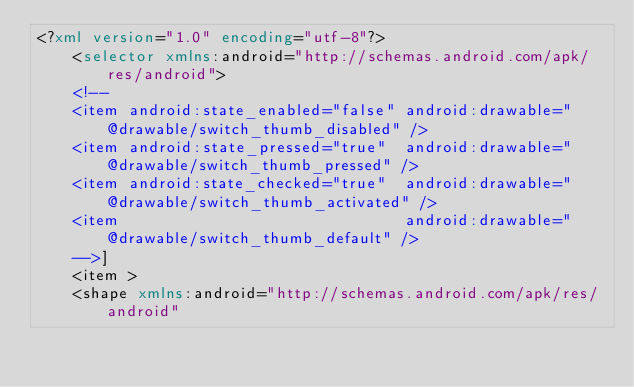<code> <loc_0><loc_0><loc_500><loc_500><_XML_><?xml version="1.0" encoding="utf-8"?>
    <selector xmlns:android="http://schemas.android.com/apk/res/android">
    <!--
    <item android:state_enabled="false" android:drawable="@drawable/switch_thumb_disabled" />
    <item android:state_pressed="true"  android:drawable="@drawable/switch_thumb_pressed" />
    <item android:state_checked="true"  android:drawable="@drawable/switch_thumb_activated" />
    <item                               android:drawable="@drawable/switch_thumb_default" />
    -->]
    <item >
    <shape xmlns:android="http://schemas.android.com/apk/res/android"</code> 